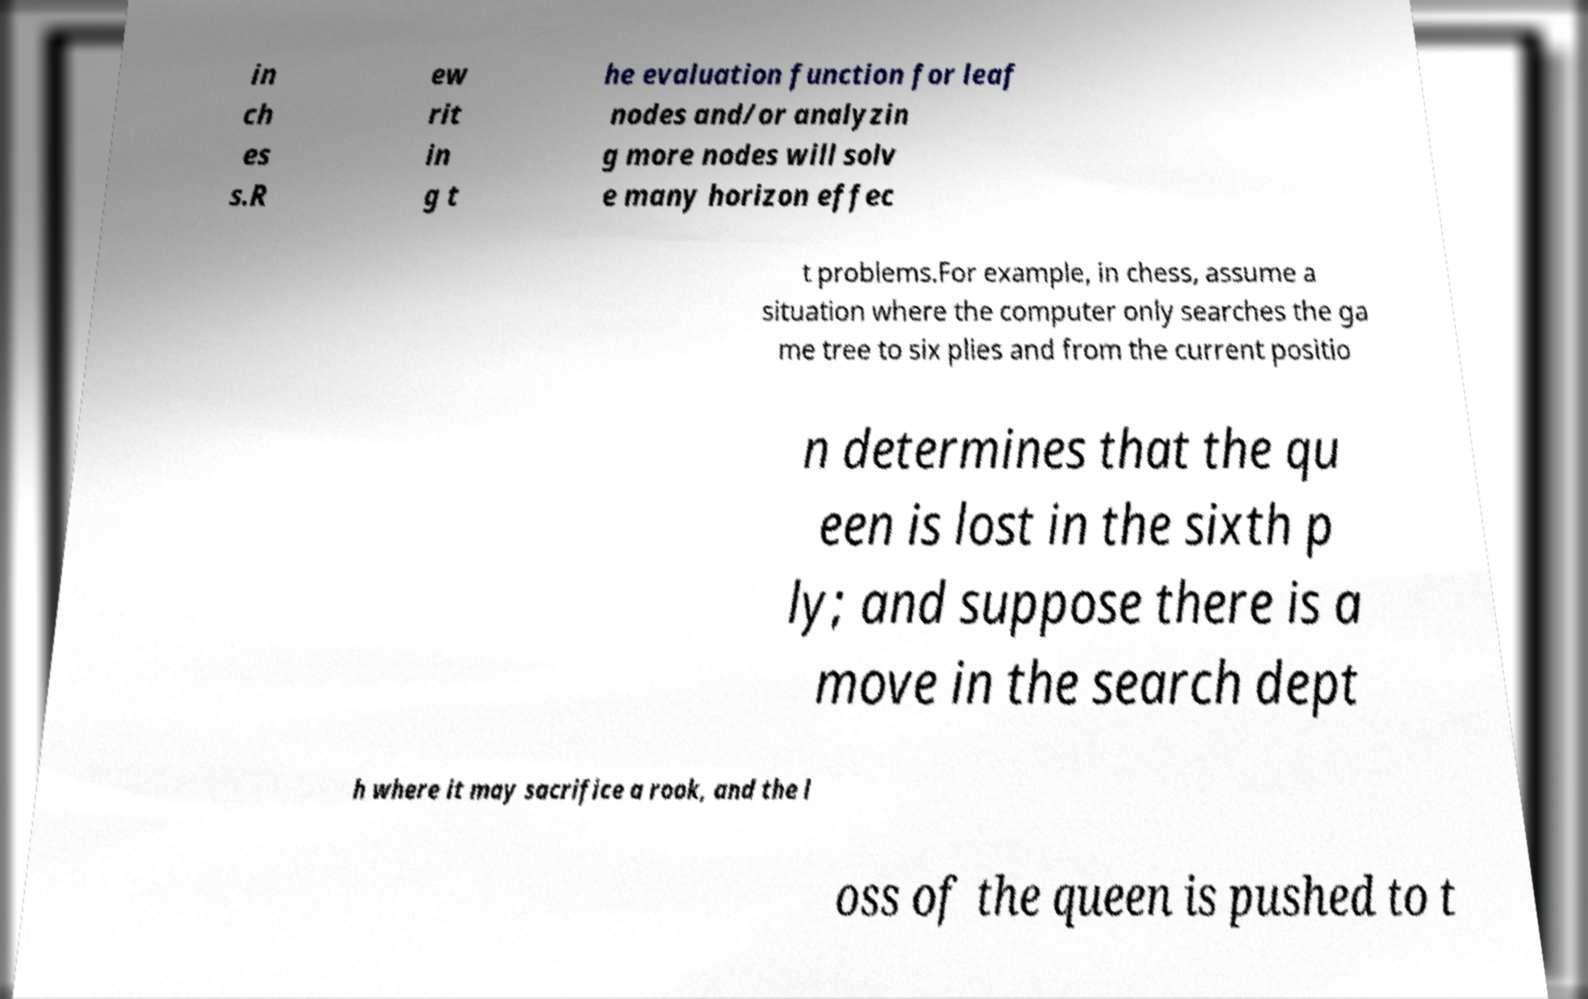Can you accurately transcribe the text from the provided image for me? in ch es s.R ew rit in g t he evaluation function for leaf nodes and/or analyzin g more nodes will solv e many horizon effec t problems.For example, in chess, assume a situation where the computer only searches the ga me tree to six plies and from the current positio n determines that the qu een is lost in the sixth p ly; and suppose there is a move in the search dept h where it may sacrifice a rook, and the l oss of the queen is pushed to t 